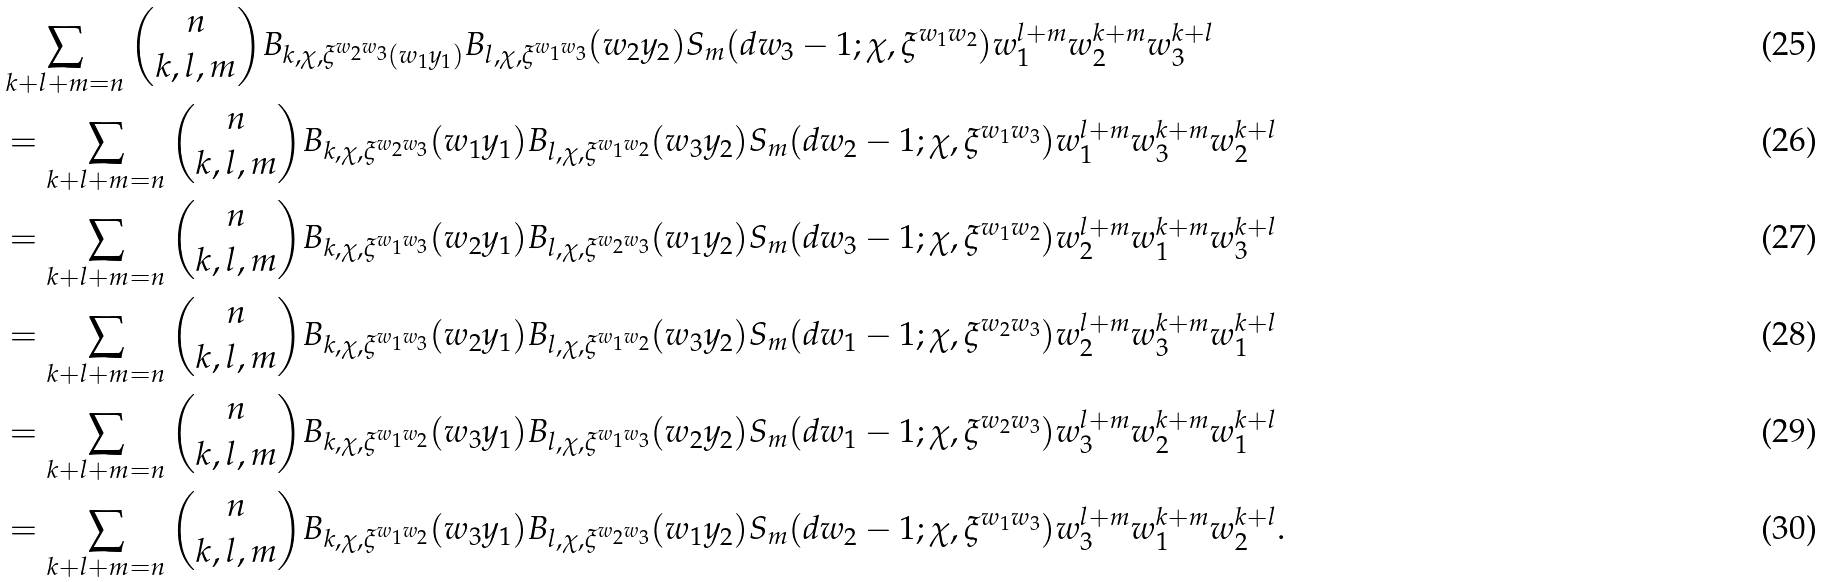Convert formula to latex. <formula><loc_0><loc_0><loc_500><loc_500>& \sum _ { k + l + m = n } \binom { n } { k , l , m } B _ { k , \chi , \xi ^ { w _ { 2 } w _ { 3 } } ( w _ { 1 } y _ { 1 } ) } B _ { l , \chi , \xi ^ { w _ { 1 } w _ { 3 } } } ( w _ { 2 } y _ { 2 } ) S _ { m } ( d w _ { 3 } - 1 ; \chi , \xi ^ { w _ { 1 } w _ { 2 } } ) w _ { 1 } ^ { l + m } w _ { 2 } ^ { k + m } w _ { 3 } ^ { k + l } \\ & = \sum _ { k + l + m = n } \binom { n } { k , l , m } B _ { k , \chi , \xi ^ { w _ { 2 } w _ { 3 } } } ( w _ { 1 } y _ { 1 } ) B _ { l , \chi , \xi ^ { w _ { 1 } w _ { 2 } } } ( w _ { 3 } y _ { 2 } ) S _ { m } ( d w _ { 2 } - 1 ; \chi , \xi ^ { w _ { 1 } w _ { 3 } } ) w _ { 1 } ^ { l + m } w _ { 3 } ^ { k + m } w _ { 2 } ^ { k + l } \\ & = \sum _ { k + l + m = n } \binom { n } { k , l , m } B _ { k , \chi , \xi ^ { w _ { 1 } w _ { 3 } } } ( w _ { 2 } y _ { 1 } ) B _ { l , \chi , \xi ^ { w _ { 2 } w _ { 3 } } } ( w _ { 1 } y _ { 2 } ) S _ { m } ( d w _ { 3 } - 1 ; \chi , \xi ^ { w _ { 1 } w _ { 2 } } ) w _ { 2 } ^ { l + m } w _ { 1 } ^ { k + m } w _ { 3 } ^ { k + l } \\ & = \sum _ { k + l + m = n } \binom { n } { k , l , m } B _ { k , \chi , \xi ^ { w _ { 1 } w _ { 3 } } } ( w _ { 2 } y _ { 1 } ) B _ { l , \chi , \xi ^ { w _ { 1 } w _ { 2 } } } ( w _ { 3 } y _ { 2 } ) S _ { m } ( d w _ { 1 } - 1 ; \chi , \xi ^ { w _ { 2 } w _ { 3 } } ) w _ { 2 } ^ { l + m } w _ { 3 } ^ { k + m } w _ { 1 } ^ { k + l } \\ & = \sum _ { k + l + m = n } \binom { n } { k , l , m } B _ { k , \chi , \xi ^ { w _ { 1 } w _ { 2 } } } ( w _ { 3 } y _ { 1 } ) B _ { l , \chi , \xi ^ { w _ { 1 } w _ { 3 } } } ( w _ { 2 } y _ { 2 } ) S _ { m } ( d w _ { 1 } - 1 ; \chi , \xi ^ { w _ { 2 } w _ { 3 } } ) w _ { 3 } ^ { l + m } w _ { 2 } ^ { k + m } w _ { 1 } ^ { k + l } \\ & = \sum _ { k + l + m = n } \binom { n } { k , l , m } B _ { k , \chi , \xi ^ { w _ { 1 } w _ { 2 } } } ( w _ { 3 } y _ { 1 } ) B _ { l , \chi , \xi ^ { w _ { 2 } w _ { 3 } } } ( w _ { 1 } y _ { 2 } ) S _ { m } ( d w _ { 2 } - 1 ; \chi , \xi ^ { w _ { 1 } w _ { 3 } } ) w _ { 3 } ^ { l + m } w _ { 1 } ^ { k + m } w _ { 2 } ^ { k + l } .</formula> 